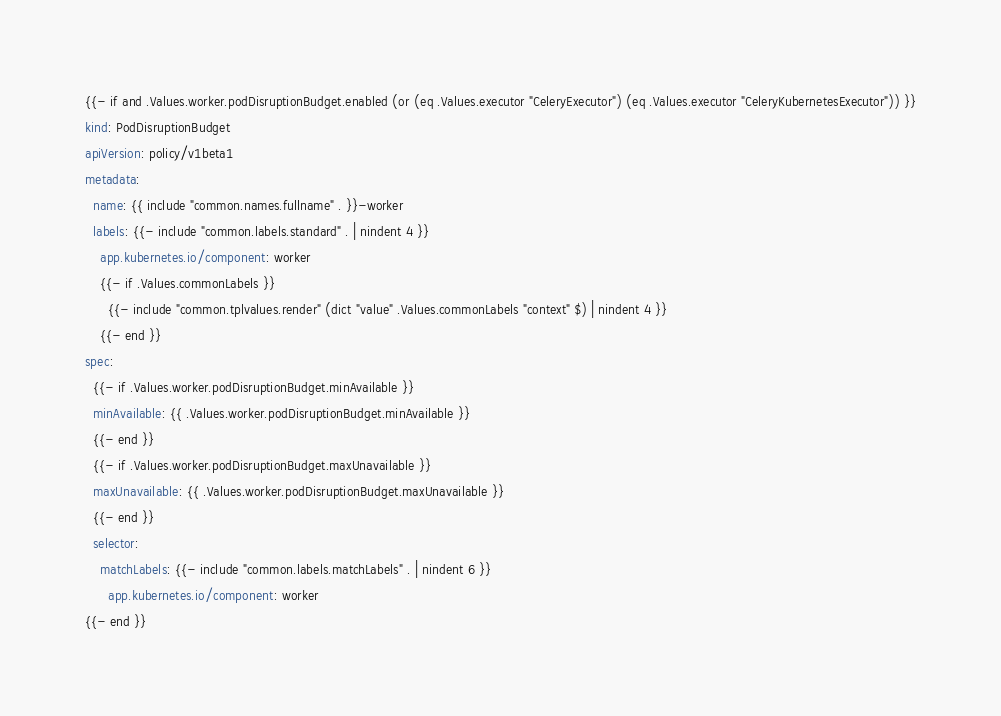<code> <loc_0><loc_0><loc_500><loc_500><_YAML_>{{- if and .Values.worker.podDisruptionBudget.enabled (or (eq .Values.executor "CeleryExecutor") (eq .Values.executor "CeleryKubernetesExecutor")) }}
kind: PodDisruptionBudget
apiVersion: policy/v1beta1
metadata:
  name: {{ include "common.names.fullname" . }}-worker
  labels: {{- include "common.labels.standard" . | nindent 4 }}
    app.kubernetes.io/component: worker
    {{- if .Values.commonLabels }}
      {{- include "common.tplvalues.render" (dict "value" .Values.commonLabels "context" $) | nindent 4 }}
    {{- end }}
spec:
  {{- if .Values.worker.podDisruptionBudget.minAvailable }}
  minAvailable: {{ .Values.worker.podDisruptionBudget.minAvailable }}
  {{- end }}
  {{- if .Values.worker.podDisruptionBudget.maxUnavailable }}
  maxUnavailable: {{ .Values.worker.podDisruptionBudget.maxUnavailable }}
  {{- end }}
  selector:
    matchLabels: {{- include "common.labels.matchLabels" . | nindent 6 }}
      app.kubernetes.io/component: worker
{{- end }}
</code> 